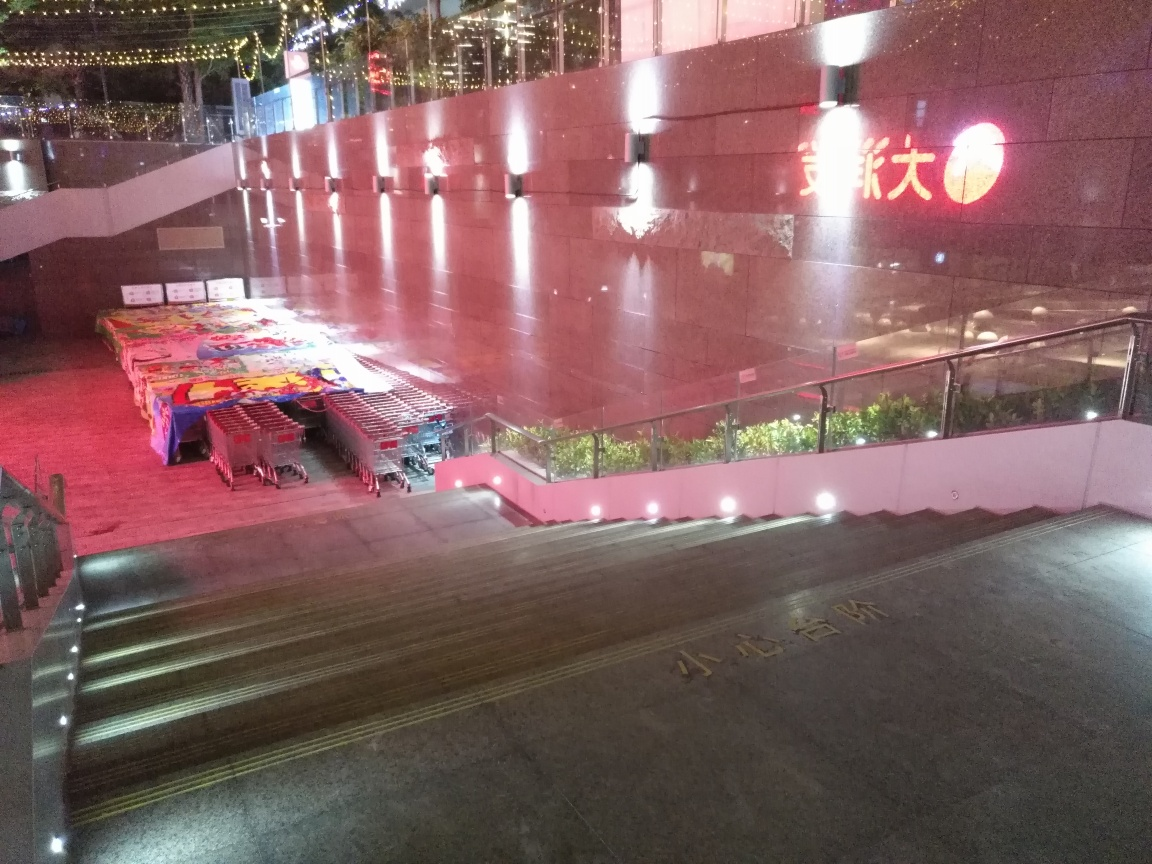What time of day does this image seem to have been taken? Based on the lighting and the absence of people, it appears the image was taken at night, after business hours when shops or nearby facilities are likely closed. 